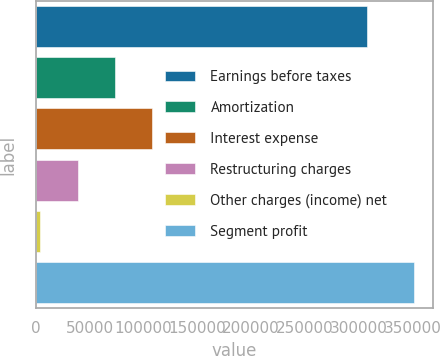Convert chart. <chart><loc_0><loc_0><loc_500><loc_500><bar_chart><fcel>Earnings before taxes<fcel>Amortization<fcel>Interest expense<fcel>Restructuring charges<fcel>Other charges (income) net<fcel>Segment profit<nl><fcel>307513<fcel>73619.6<fcel>108347<fcel>38891.8<fcel>4164<fcel>351442<nl></chart> 